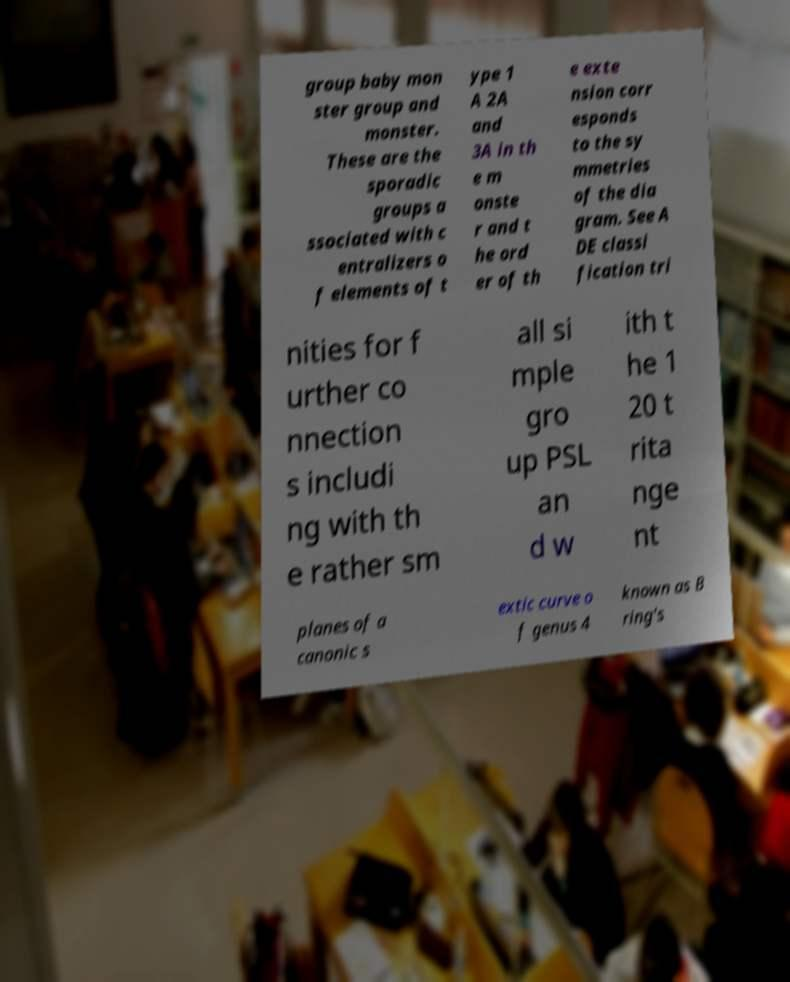Please read and relay the text visible in this image. What does it say? group baby mon ster group and monster. These are the sporadic groups a ssociated with c entralizers o f elements of t ype 1 A 2A and 3A in th e m onste r and t he ord er of th e exte nsion corr esponds to the sy mmetries of the dia gram. See A DE classi fication tri nities for f urther co nnection s includi ng with th e rather sm all si mple gro up PSL an d w ith t he 1 20 t rita nge nt planes of a canonic s extic curve o f genus 4 known as B ring's 